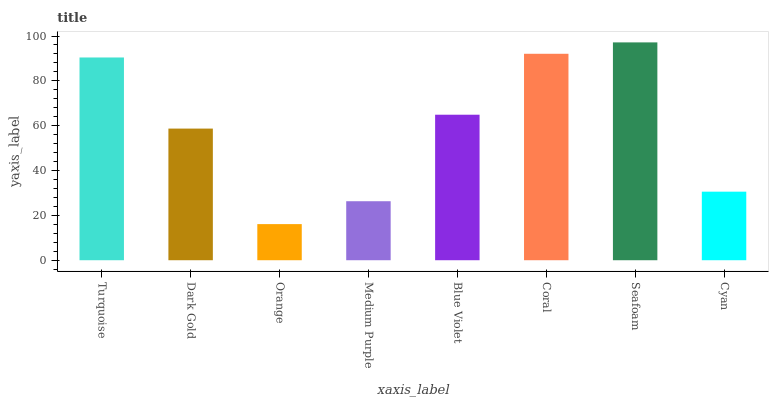Is Orange the minimum?
Answer yes or no. Yes. Is Seafoam the maximum?
Answer yes or no. Yes. Is Dark Gold the minimum?
Answer yes or no. No. Is Dark Gold the maximum?
Answer yes or no. No. Is Turquoise greater than Dark Gold?
Answer yes or no. Yes. Is Dark Gold less than Turquoise?
Answer yes or no. Yes. Is Dark Gold greater than Turquoise?
Answer yes or no. No. Is Turquoise less than Dark Gold?
Answer yes or no. No. Is Blue Violet the high median?
Answer yes or no. Yes. Is Dark Gold the low median?
Answer yes or no. Yes. Is Medium Purple the high median?
Answer yes or no. No. Is Cyan the low median?
Answer yes or no. No. 